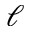Convert formula to latex. <formula><loc_0><loc_0><loc_500><loc_500>\ell</formula> 